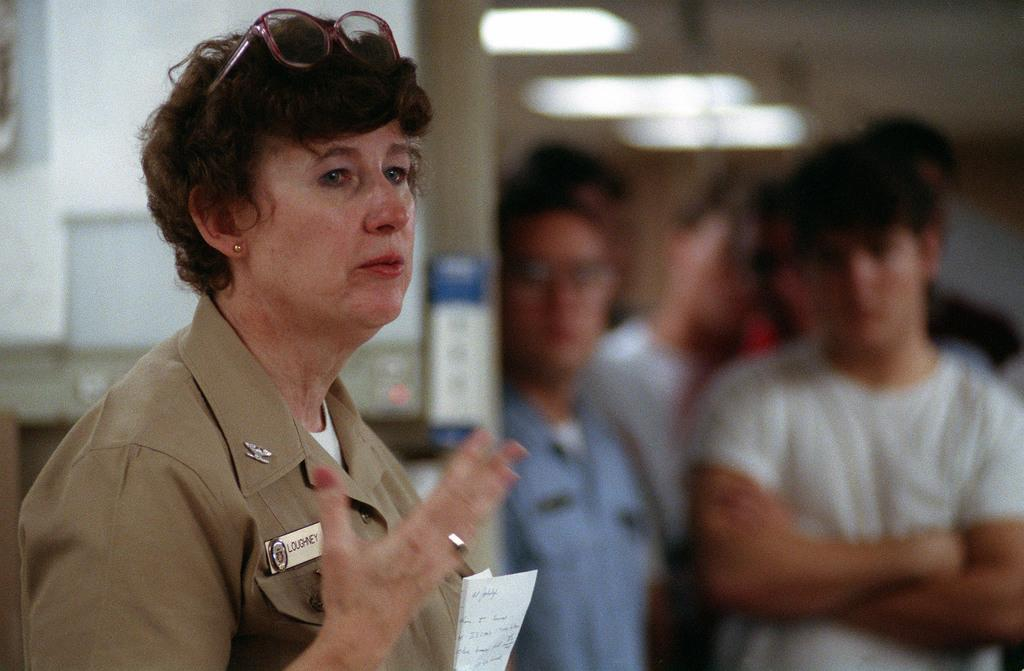Who is present in the image? There is a woman in the image. What is the woman holding in the image? The woman is holding some paper. Can you describe the background of the image? The background of the image is blurry. What type of bird can be seen flying through the hole in the image? There is no bird or hole present in the image. Is there a boat visible in the image? No, there is no boat present in the image. 